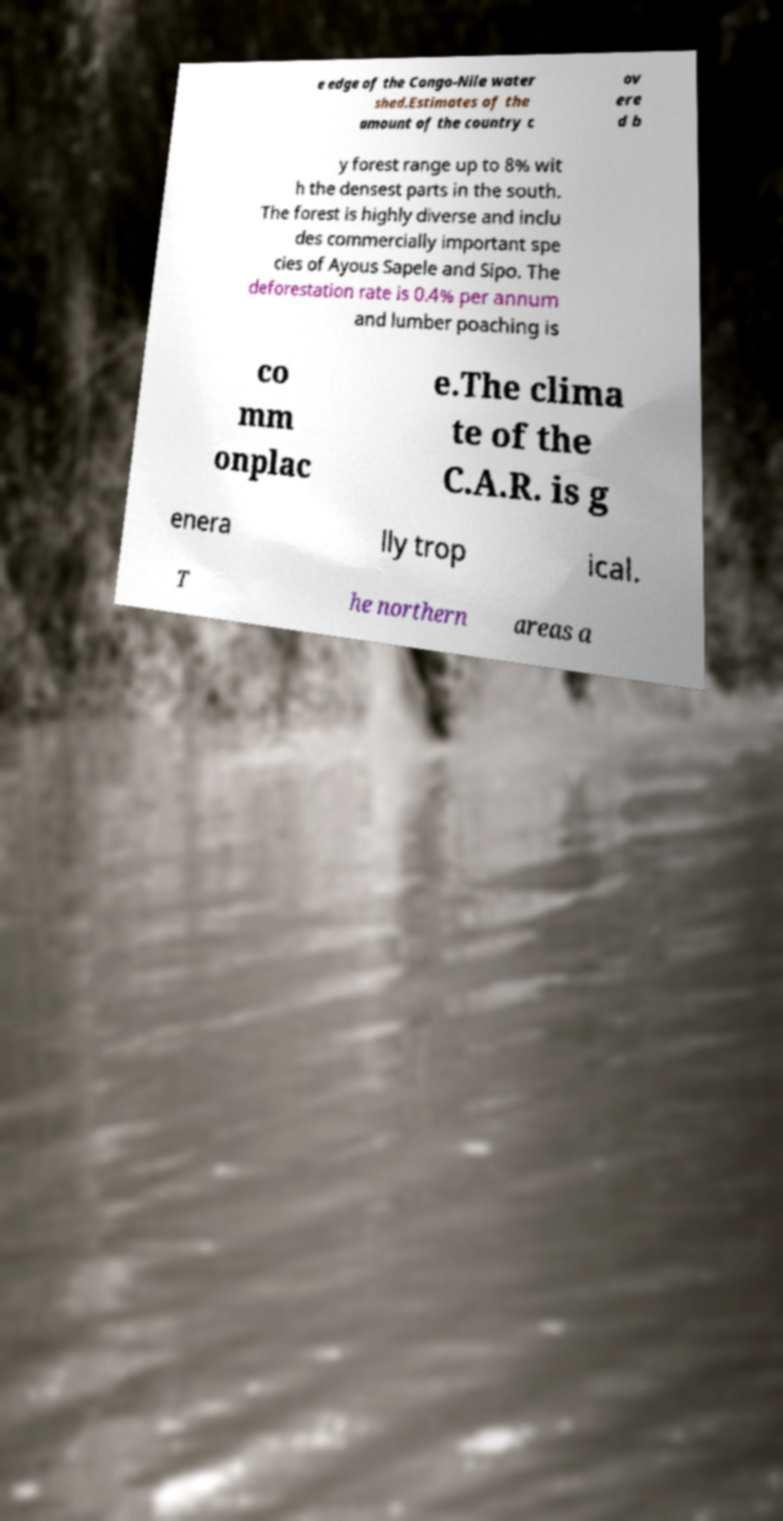What messages or text are displayed in this image? I need them in a readable, typed format. e edge of the Congo-Nile water shed.Estimates of the amount of the country c ov ere d b y forest range up to 8% wit h the densest parts in the south. The forest is highly diverse and inclu des commercially important spe cies of Ayous Sapele and Sipo. The deforestation rate is 0.4% per annum and lumber poaching is co mm onplac e.The clima te of the C.A.R. is g enera lly trop ical. T he northern areas a 